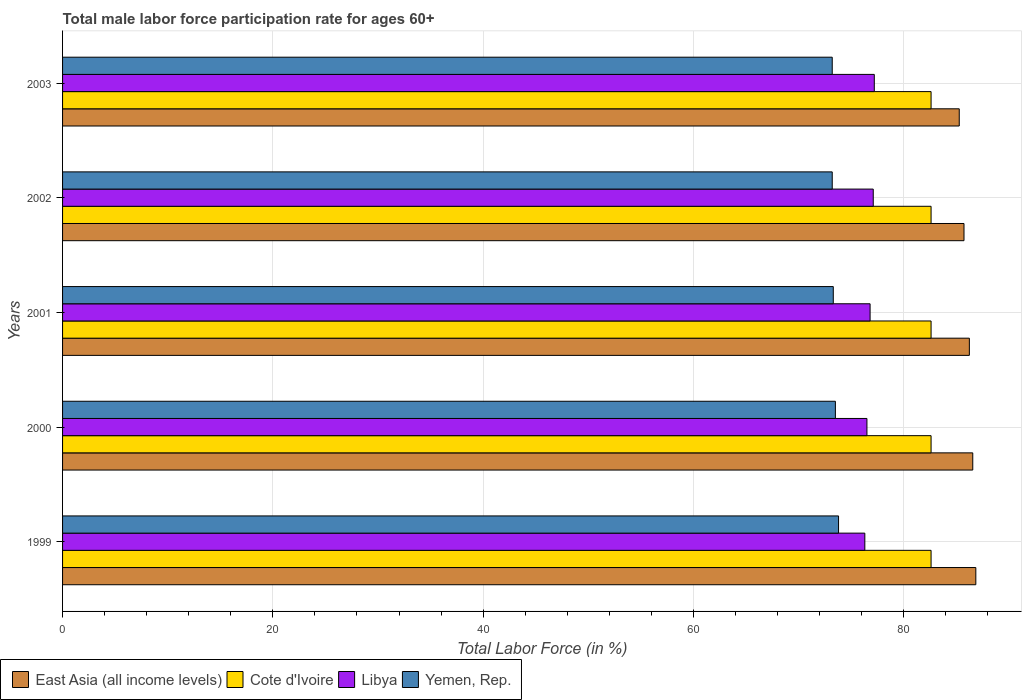How many different coloured bars are there?
Offer a very short reply. 4. How many groups of bars are there?
Provide a succinct answer. 5. Are the number of bars on each tick of the Y-axis equal?
Keep it short and to the point. Yes. What is the label of the 4th group of bars from the top?
Make the answer very short. 2000. In how many cases, is the number of bars for a given year not equal to the number of legend labels?
Your answer should be compact. 0. What is the male labor force participation rate in Cote d'Ivoire in 1999?
Keep it short and to the point. 82.6. Across all years, what is the maximum male labor force participation rate in Yemen, Rep.?
Offer a very short reply. 73.8. Across all years, what is the minimum male labor force participation rate in East Asia (all income levels)?
Keep it short and to the point. 85.28. What is the total male labor force participation rate in Yemen, Rep. in the graph?
Keep it short and to the point. 367. What is the difference between the male labor force participation rate in East Asia (all income levels) in 2002 and that in 2003?
Offer a very short reply. 0.45. What is the difference between the male labor force participation rate in Libya in 2000 and the male labor force participation rate in Cote d'Ivoire in 2002?
Offer a terse response. -6.1. What is the average male labor force participation rate in East Asia (all income levels) per year?
Your answer should be very brief. 86.13. In the year 2002, what is the difference between the male labor force participation rate in East Asia (all income levels) and male labor force participation rate in Libya?
Offer a very short reply. 8.63. Is the male labor force participation rate in East Asia (all income levels) in 1999 less than that in 2001?
Give a very brief answer. No. What is the difference between the highest and the second highest male labor force participation rate in Cote d'Ivoire?
Ensure brevity in your answer.  0. What is the difference between the highest and the lowest male labor force participation rate in Cote d'Ivoire?
Offer a terse response. 0. Is it the case that in every year, the sum of the male labor force participation rate in Cote d'Ivoire and male labor force participation rate in Yemen, Rep. is greater than the sum of male labor force participation rate in Libya and male labor force participation rate in East Asia (all income levels)?
Your answer should be very brief. Yes. What does the 2nd bar from the top in 2001 represents?
Offer a very short reply. Libya. What does the 2nd bar from the bottom in 2002 represents?
Provide a succinct answer. Cote d'Ivoire. How many bars are there?
Ensure brevity in your answer.  20. Are the values on the major ticks of X-axis written in scientific E-notation?
Your answer should be compact. No. Does the graph contain any zero values?
Your answer should be compact. No. How many legend labels are there?
Your answer should be very brief. 4. How are the legend labels stacked?
Offer a very short reply. Horizontal. What is the title of the graph?
Provide a succinct answer. Total male labor force participation rate for ages 60+. What is the label or title of the Y-axis?
Ensure brevity in your answer.  Years. What is the Total Labor Force (in %) of East Asia (all income levels) in 1999?
Provide a succinct answer. 86.86. What is the Total Labor Force (in %) of Cote d'Ivoire in 1999?
Your answer should be very brief. 82.6. What is the Total Labor Force (in %) in Libya in 1999?
Ensure brevity in your answer.  76.3. What is the Total Labor Force (in %) in Yemen, Rep. in 1999?
Keep it short and to the point. 73.8. What is the Total Labor Force (in %) of East Asia (all income levels) in 2000?
Provide a short and direct response. 86.56. What is the Total Labor Force (in %) in Cote d'Ivoire in 2000?
Keep it short and to the point. 82.6. What is the Total Labor Force (in %) in Libya in 2000?
Your answer should be very brief. 76.5. What is the Total Labor Force (in %) of Yemen, Rep. in 2000?
Keep it short and to the point. 73.5. What is the Total Labor Force (in %) of East Asia (all income levels) in 2001?
Give a very brief answer. 86.24. What is the Total Labor Force (in %) of Cote d'Ivoire in 2001?
Give a very brief answer. 82.6. What is the Total Labor Force (in %) in Libya in 2001?
Your answer should be very brief. 76.8. What is the Total Labor Force (in %) of Yemen, Rep. in 2001?
Your answer should be very brief. 73.3. What is the Total Labor Force (in %) in East Asia (all income levels) in 2002?
Your answer should be compact. 85.73. What is the Total Labor Force (in %) of Cote d'Ivoire in 2002?
Make the answer very short. 82.6. What is the Total Labor Force (in %) in Libya in 2002?
Provide a short and direct response. 77.1. What is the Total Labor Force (in %) of Yemen, Rep. in 2002?
Offer a very short reply. 73.2. What is the Total Labor Force (in %) of East Asia (all income levels) in 2003?
Your response must be concise. 85.28. What is the Total Labor Force (in %) in Cote d'Ivoire in 2003?
Offer a very short reply. 82.6. What is the Total Labor Force (in %) in Libya in 2003?
Give a very brief answer. 77.2. What is the Total Labor Force (in %) of Yemen, Rep. in 2003?
Give a very brief answer. 73.2. Across all years, what is the maximum Total Labor Force (in %) in East Asia (all income levels)?
Ensure brevity in your answer.  86.86. Across all years, what is the maximum Total Labor Force (in %) in Cote d'Ivoire?
Keep it short and to the point. 82.6. Across all years, what is the maximum Total Labor Force (in %) of Libya?
Offer a very short reply. 77.2. Across all years, what is the maximum Total Labor Force (in %) in Yemen, Rep.?
Provide a succinct answer. 73.8. Across all years, what is the minimum Total Labor Force (in %) in East Asia (all income levels)?
Your answer should be compact. 85.28. Across all years, what is the minimum Total Labor Force (in %) in Cote d'Ivoire?
Give a very brief answer. 82.6. Across all years, what is the minimum Total Labor Force (in %) in Libya?
Ensure brevity in your answer.  76.3. Across all years, what is the minimum Total Labor Force (in %) in Yemen, Rep.?
Offer a very short reply. 73.2. What is the total Total Labor Force (in %) in East Asia (all income levels) in the graph?
Offer a terse response. 430.67. What is the total Total Labor Force (in %) in Cote d'Ivoire in the graph?
Keep it short and to the point. 413. What is the total Total Labor Force (in %) in Libya in the graph?
Your answer should be very brief. 383.9. What is the total Total Labor Force (in %) of Yemen, Rep. in the graph?
Your response must be concise. 367. What is the difference between the Total Labor Force (in %) of East Asia (all income levels) in 1999 and that in 2000?
Provide a succinct answer. 0.29. What is the difference between the Total Labor Force (in %) in Libya in 1999 and that in 2000?
Provide a short and direct response. -0.2. What is the difference between the Total Labor Force (in %) of Yemen, Rep. in 1999 and that in 2000?
Give a very brief answer. 0.3. What is the difference between the Total Labor Force (in %) of East Asia (all income levels) in 1999 and that in 2001?
Provide a succinct answer. 0.62. What is the difference between the Total Labor Force (in %) of Cote d'Ivoire in 1999 and that in 2001?
Provide a short and direct response. 0. What is the difference between the Total Labor Force (in %) of Yemen, Rep. in 1999 and that in 2001?
Your answer should be compact. 0.5. What is the difference between the Total Labor Force (in %) of East Asia (all income levels) in 1999 and that in 2002?
Make the answer very short. 1.13. What is the difference between the Total Labor Force (in %) of Cote d'Ivoire in 1999 and that in 2002?
Keep it short and to the point. 0. What is the difference between the Total Labor Force (in %) in East Asia (all income levels) in 1999 and that in 2003?
Keep it short and to the point. 1.58. What is the difference between the Total Labor Force (in %) in Libya in 1999 and that in 2003?
Your response must be concise. -0.9. What is the difference between the Total Labor Force (in %) in East Asia (all income levels) in 2000 and that in 2001?
Provide a succinct answer. 0.32. What is the difference between the Total Labor Force (in %) of Cote d'Ivoire in 2000 and that in 2001?
Provide a succinct answer. 0. What is the difference between the Total Labor Force (in %) in Libya in 2000 and that in 2001?
Provide a short and direct response. -0.3. What is the difference between the Total Labor Force (in %) in East Asia (all income levels) in 2000 and that in 2002?
Provide a succinct answer. 0.83. What is the difference between the Total Labor Force (in %) in East Asia (all income levels) in 2000 and that in 2003?
Provide a succinct answer. 1.28. What is the difference between the Total Labor Force (in %) of Cote d'Ivoire in 2000 and that in 2003?
Give a very brief answer. 0. What is the difference between the Total Labor Force (in %) of Yemen, Rep. in 2000 and that in 2003?
Your response must be concise. 0.3. What is the difference between the Total Labor Force (in %) in East Asia (all income levels) in 2001 and that in 2002?
Offer a very short reply. 0.51. What is the difference between the Total Labor Force (in %) of Libya in 2001 and that in 2002?
Offer a terse response. -0.3. What is the difference between the Total Labor Force (in %) in Yemen, Rep. in 2001 and that in 2002?
Provide a short and direct response. 0.1. What is the difference between the Total Labor Force (in %) of East Asia (all income levels) in 2001 and that in 2003?
Your answer should be very brief. 0.96. What is the difference between the Total Labor Force (in %) of Cote d'Ivoire in 2001 and that in 2003?
Give a very brief answer. 0. What is the difference between the Total Labor Force (in %) of Libya in 2001 and that in 2003?
Your answer should be very brief. -0.4. What is the difference between the Total Labor Force (in %) of Yemen, Rep. in 2001 and that in 2003?
Provide a succinct answer. 0.1. What is the difference between the Total Labor Force (in %) of East Asia (all income levels) in 2002 and that in 2003?
Give a very brief answer. 0.45. What is the difference between the Total Labor Force (in %) in Libya in 2002 and that in 2003?
Offer a very short reply. -0.1. What is the difference between the Total Labor Force (in %) of East Asia (all income levels) in 1999 and the Total Labor Force (in %) of Cote d'Ivoire in 2000?
Keep it short and to the point. 4.26. What is the difference between the Total Labor Force (in %) of East Asia (all income levels) in 1999 and the Total Labor Force (in %) of Libya in 2000?
Make the answer very short. 10.36. What is the difference between the Total Labor Force (in %) in East Asia (all income levels) in 1999 and the Total Labor Force (in %) in Yemen, Rep. in 2000?
Ensure brevity in your answer.  13.36. What is the difference between the Total Labor Force (in %) of Cote d'Ivoire in 1999 and the Total Labor Force (in %) of Libya in 2000?
Offer a very short reply. 6.1. What is the difference between the Total Labor Force (in %) of East Asia (all income levels) in 1999 and the Total Labor Force (in %) of Cote d'Ivoire in 2001?
Your response must be concise. 4.26. What is the difference between the Total Labor Force (in %) of East Asia (all income levels) in 1999 and the Total Labor Force (in %) of Libya in 2001?
Ensure brevity in your answer.  10.06. What is the difference between the Total Labor Force (in %) of East Asia (all income levels) in 1999 and the Total Labor Force (in %) of Yemen, Rep. in 2001?
Your answer should be compact. 13.56. What is the difference between the Total Labor Force (in %) of Cote d'Ivoire in 1999 and the Total Labor Force (in %) of Libya in 2001?
Your response must be concise. 5.8. What is the difference between the Total Labor Force (in %) in Cote d'Ivoire in 1999 and the Total Labor Force (in %) in Yemen, Rep. in 2001?
Keep it short and to the point. 9.3. What is the difference between the Total Labor Force (in %) in Libya in 1999 and the Total Labor Force (in %) in Yemen, Rep. in 2001?
Keep it short and to the point. 3. What is the difference between the Total Labor Force (in %) of East Asia (all income levels) in 1999 and the Total Labor Force (in %) of Cote d'Ivoire in 2002?
Ensure brevity in your answer.  4.26. What is the difference between the Total Labor Force (in %) of East Asia (all income levels) in 1999 and the Total Labor Force (in %) of Libya in 2002?
Your answer should be compact. 9.76. What is the difference between the Total Labor Force (in %) in East Asia (all income levels) in 1999 and the Total Labor Force (in %) in Yemen, Rep. in 2002?
Keep it short and to the point. 13.66. What is the difference between the Total Labor Force (in %) of Cote d'Ivoire in 1999 and the Total Labor Force (in %) of Libya in 2002?
Give a very brief answer. 5.5. What is the difference between the Total Labor Force (in %) of East Asia (all income levels) in 1999 and the Total Labor Force (in %) of Cote d'Ivoire in 2003?
Your answer should be compact. 4.26. What is the difference between the Total Labor Force (in %) of East Asia (all income levels) in 1999 and the Total Labor Force (in %) of Libya in 2003?
Your answer should be compact. 9.66. What is the difference between the Total Labor Force (in %) in East Asia (all income levels) in 1999 and the Total Labor Force (in %) in Yemen, Rep. in 2003?
Your answer should be very brief. 13.66. What is the difference between the Total Labor Force (in %) in Cote d'Ivoire in 1999 and the Total Labor Force (in %) in Yemen, Rep. in 2003?
Offer a terse response. 9.4. What is the difference between the Total Labor Force (in %) in Libya in 1999 and the Total Labor Force (in %) in Yemen, Rep. in 2003?
Your response must be concise. 3.1. What is the difference between the Total Labor Force (in %) in East Asia (all income levels) in 2000 and the Total Labor Force (in %) in Cote d'Ivoire in 2001?
Give a very brief answer. 3.96. What is the difference between the Total Labor Force (in %) of East Asia (all income levels) in 2000 and the Total Labor Force (in %) of Libya in 2001?
Offer a very short reply. 9.76. What is the difference between the Total Labor Force (in %) in East Asia (all income levels) in 2000 and the Total Labor Force (in %) in Yemen, Rep. in 2001?
Offer a very short reply. 13.26. What is the difference between the Total Labor Force (in %) in East Asia (all income levels) in 2000 and the Total Labor Force (in %) in Cote d'Ivoire in 2002?
Your answer should be compact. 3.96. What is the difference between the Total Labor Force (in %) of East Asia (all income levels) in 2000 and the Total Labor Force (in %) of Libya in 2002?
Your answer should be compact. 9.46. What is the difference between the Total Labor Force (in %) in East Asia (all income levels) in 2000 and the Total Labor Force (in %) in Yemen, Rep. in 2002?
Your answer should be compact. 13.36. What is the difference between the Total Labor Force (in %) of Cote d'Ivoire in 2000 and the Total Labor Force (in %) of Libya in 2002?
Give a very brief answer. 5.5. What is the difference between the Total Labor Force (in %) of Libya in 2000 and the Total Labor Force (in %) of Yemen, Rep. in 2002?
Make the answer very short. 3.3. What is the difference between the Total Labor Force (in %) of East Asia (all income levels) in 2000 and the Total Labor Force (in %) of Cote d'Ivoire in 2003?
Keep it short and to the point. 3.96. What is the difference between the Total Labor Force (in %) of East Asia (all income levels) in 2000 and the Total Labor Force (in %) of Libya in 2003?
Offer a very short reply. 9.36. What is the difference between the Total Labor Force (in %) of East Asia (all income levels) in 2000 and the Total Labor Force (in %) of Yemen, Rep. in 2003?
Offer a terse response. 13.36. What is the difference between the Total Labor Force (in %) of Cote d'Ivoire in 2000 and the Total Labor Force (in %) of Yemen, Rep. in 2003?
Your answer should be very brief. 9.4. What is the difference between the Total Labor Force (in %) of Libya in 2000 and the Total Labor Force (in %) of Yemen, Rep. in 2003?
Offer a terse response. 3.3. What is the difference between the Total Labor Force (in %) of East Asia (all income levels) in 2001 and the Total Labor Force (in %) of Cote d'Ivoire in 2002?
Offer a terse response. 3.64. What is the difference between the Total Labor Force (in %) of East Asia (all income levels) in 2001 and the Total Labor Force (in %) of Libya in 2002?
Provide a succinct answer. 9.14. What is the difference between the Total Labor Force (in %) of East Asia (all income levels) in 2001 and the Total Labor Force (in %) of Yemen, Rep. in 2002?
Keep it short and to the point. 13.04. What is the difference between the Total Labor Force (in %) in Cote d'Ivoire in 2001 and the Total Labor Force (in %) in Libya in 2002?
Keep it short and to the point. 5.5. What is the difference between the Total Labor Force (in %) in Cote d'Ivoire in 2001 and the Total Labor Force (in %) in Yemen, Rep. in 2002?
Your response must be concise. 9.4. What is the difference between the Total Labor Force (in %) in East Asia (all income levels) in 2001 and the Total Labor Force (in %) in Cote d'Ivoire in 2003?
Keep it short and to the point. 3.64. What is the difference between the Total Labor Force (in %) in East Asia (all income levels) in 2001 and the Total Labor Force (in %) in Libya in 2003?
Your response must be concise. 9.04. What is the difference between the Total Labor Force (in %) of East Asia (all income levels) in 2001 and the Total Labor Force (in %) of Yemen, Rep. in 2003?
Offer a terse response. 13.04. What is the difference between the Total Labor Force (in %) of Libya in 2001 and the Total Labor Force (in %) of Yemen, Rep. in 2003?
Give a very brief answer. 3.6. What is the difference between the Total Labor Force (in %) of East Asia (all income levels) in 2002 and the Total Labor Force (in %) of Cote d'Ivoire in 2003?
Keep it short and to the point. 3.13. What is the difference between the Total Labor Force (in %) of East Asia (all income levels) in 2002 and the Total Labor Force (in %) of Libya in 2003?
Provide a short and direct response. 8.53. What is the difference between the Total Labor Force (in %) of East Asia (all income levels) in 2002 and the Total Labor Force (in %) of Yemen, Rep. in 2003?
Provide a succinct answer. 12.53. What is the difference between the Total Labor Force (in %) in Cote d'Ivoire in 2002 and the Total Labor Force (in %) in Yemen, Rep. in 2003?
Ensure brevity in your answer.  9.4. What is the average Total Labor Force (in %) of East Asia (all income levels) per year?
Offer a terse response. 86.13. What is the average Total Labor Force (in %) of Cote d'Ivoire per year?
Your answer should be compact. 82.6. What is the average Total Labor Force (in %) in Libya per year?
Provide a short and direct response. 76.78. What is the average Total Labor Force (in %) in Yemen, Rep. per year?
Ensure brevity in your answer.  73.4. In the year 1999, what is the difference between the Total Labor Force (in %) of East Asia (all income levels) and Total Labor Force (in %) of Cote d'Ivoire?
Give a very brief answer. 4.26. In the year 1999, what is the difference between the Total Labor Force (in %) of East Asia (all income levels) and Total Labor Force (in %) of Libya?
Give a very brief answer. 10.56. In the year 1999, what is the difference between the Total Labor Force (in %) in East Asia (all income levels) and Total Labor Force (in %) in Yemen, Rep.?
Your answer should be very brief. 13.06. In the year 1999, what is the difference between the Total Labor Force (in %) of Cote d'Ivoire and Total Labor Force (in %) of Yemen, Rep.?
Provide a succinct answer. 8.8. In the year 1999, what is the difference between the Total Labor Force (in %) of Libya and Total Labor Force (in %) of Yemen, Rep.?
Make the answer very short. 2.5. In the year 2000, what is the difference between the Total Labor Force (in %) of East Asia (all income levels) and Total Labor Force (in %) of Cote d'Ivoire?
Make the answer very short. 3.96. In the year 2000, what is the difference between the Total Labor Force (in %) in East Asia (all income levels) and Total Labor Force (in %) in Libya?
Make the answer very short. 10.06. In the year 2000, what is the difference between the Total Labor Force (in %) in East Asia (all income levels) and Total Labor Force (in %) in Yemen, Rep.?
Make the answer very short. 13.06. In the year 2000, what is the difference between the Total Labor Force (in %) in Cote d'Ivoire and Total Labor Force (in %) in Libya?
Offer a very short reply. 6.1. In the year 2000, what is the difference between the Total Labor Force (in %) in Cote d'Ivoire and Total Labor Force (in %) in Yemen, Rep.?
Keep it short and to the point. 9.1. In the year 2000, what is the difference between the Total Labor Force (in %) of Libya and Total Labor Force (in %) of Yemen, Rep.?
Keep it short and to the point. 3. In the year 2001, what is the difference between the Total Labor Force (in %) of East Asia (all income levels) and Total Labor Force (in %) of Cote d'Ivoire?
Give a very brief answer. 3.64. In the year 2001, what is the difference between the Total Labor Force (in %) of East Asia (all income levels) and Total Labor Force (in %) of Libya?
Your answer should be very brief. 9.44. In the year 2001, what is the difference between the Total Labor Force (in %) in East Asia (all income levels) and Total Labor Force (in %) in Yemen, Rep.?
Your answer should be compact. 12.94. In the year 2001, what is the difference between the Total Labor Force (in %) in Cote d'Ivoire and Total Labor Force (in %) in Yemen, Rep.?
Make the answer very short. 9.3. In the year 2001, what is the difference between the Total Labor Force (in %) in Libya and Total Labor Force (in %) in Yemen, Rep.?
Ensure brevity in your answer.  3.5. In the year 2002, what is the difference between the Total Labor Force (in %) of East Asia (all income levels) and Total Labor Force (in %) of Cote d'Ivoire?
Offer a very short reply. 3.13. In the year 2002, what is the difference between the Total Labor Force (in %) of East Asia (all income levels) and Total Labor Force (in %) of Libya?
Your response must be concise. 8.63. In the year 2002, what is the difference between the Total Labor Force (in %) in East Asia (all income levels) and Total Labor Force (in %) in Yemen, Rep.?
Offer a very short reply. 12.53. In the year 2002, what is the difference between the Total Labor Force (in %) in Cote d'Ivoire and Total Labor Force (in %) in Libya?
Offer a terse response. 5.5. In the year 2002, what is the difference between the Total Labor Force (in %) of Cote d'Ivoire and Total Labor Force (in %) of Yemen, Rep.?
Provide a short and direct response. 9.4. In the year 2002, what is the difference between the Total Labor Force (in %) of Libya and Total Labor Force (in %) of Yemen, Rep.?
Your response must be concise. 3.9. In the year 2003, what is the difference between the Total Labor Force (in %) in East Asia (all income levels) and Total Labor Force (in %) in Cote d'Ivoire?
Offer a very short reply. 2.68. In the year 2003, what is the difference between the Total Labor Force (in %) in East Asia (all income levels) and Total Labor Force (in %) in Libya?
Give a very brief answer. 8.08. In the year 2003, what is the difference between the Total Labor Force (in %) of East Asia (all income levels) and Total Labor Force (in %) of Yemen, Rep.?
Ensure brevity in your answer.  12.08. In the year 2003, what is the difference between the Total Labor Force (in %) in Cote d'Ivoire and Total Labor Force (in %) in Libya?
Provide a short and direct response. 5.4. What is the ratio of the Total Labor Force (in %) of Cote d'Ivoire in 1999 to that in 2000?
Ensure brevity in your answer.  1. What is the ratio of the Total Labor Force (in %) of Libya in 1999 to that in 2000?
Your answer should be compact. 1. What is the ratio of the Total Labor Force (in %) in East Asia (all income levels) in 1999 to that in 2001?
Your answer should be very brief. 1.01. What is the ratio of the Total Labor Force (in %) in Cote d'Ivoire in 1999 to that in 2001?
Provide a succinct answer. 1. What is the ratio of the Total Labor Force (in %) of Yemen, Rep. in 1999 to that in 2001?
Keep it short and to the point. 1.01. What is the ratio of the Total Labor Force (in %) of East Asia (all income levels) in 1999 to that in 2002?
Make the answer very short. 1.01. What is the ratio of the Total Labor Force (in %) in Cote d'Ivoire in 1999 to that in 2002?
Your answer should be compact. 1. What is the ratio of the Total Labor Force (in %) in Libya in 1999 to that in 2002?
Keep it short and to the point. 0.99. What is the ratio of the Total Labor Force (in %) in Yemen, Rep. in 1999 to that in 2002?
Offer a terse response. 1.01. What is the ratio of the Total Labor Force (in %) of East Asia (all income levels) in 1999 to that in 2003?
Your answer should be compact. 1.02. What is the ratio of the Total Labor Force (in %) in Libya in 1999 to that in 2003?
Make the answer very short. 0.99. What is the ratio of the Total Labor Force (in %) of Yemen, Rep. in 1999 to that in 2003?
Provide a succinct answer. 1.01. What is the ratio of the Total Labor Force (in %) of Cote d'Ivoire in 2000 to that in 2001?
Provide a succinct answer. 1. What is the ratio of the Total Labor Force (in %) in East Asia (all income levels) in 2000 to that in 2002?
Your answer should be very brief. 1.01. What is the ratio of the Total Labor Force (in %) in Cote d'Ivoire in 2000 to that in 2002?
Provide a succinct answer. 1. What is the ratio of the Total Labor Force (in %) of Libya in 2000 to that in 2002?
Ensure brevity in your answer.  0.99. What is the ratio of the Total Labor Force (in %) of East Asia (all income levels) in 2000 to that in 2003?
Make the answer very short. 1.02. What is the ratio of the Total Labor Force (in %) in Cote d'Ivoire in 2000 to that in 2003?
Your response must be concise. 1. What is the ratio of the Total Labor Force (in %) in Libya in 2000 to that in 2003?
Provide a short and direct response. 0.99. What is the ratio of the Total Labor Force (in %) in Yemen, Rep. in 2000 to that in 2003?
Ensure brevity in your answer.  1. What is the ratio of the Total Labor Force (in %) of Cote d'Ivoire in 2001 to that in 2002?
Your answer should be very brief. 1. What is the ratio of the Total Labor Force (in %) of Yemen, Rep. in 2001 to that in 2002?
Give a very brief answer. 1. What is the ratio of the Total Labor Force (in %) of East Asia (all income levels) in 2001 to that in 2003?
Offer a very short reply. 1.01. What is the ratio of the Total Labor Force (in %) in Cote d'Ivoire in 2001 to that in 2003?
Ensure brevity in your answer.  1. What is the ratio of the Total Labor Force (in %) in Yemen, Rep. in 2001 to that in 2003?
Offer a very short reply. 1. What is the ratio of the Total Labor Force (in %) of East Asia (all income levels) in 2002 to that in 2003?
Provide a short and direct response. 1.01. What is the ratio of the Total Labor Force (in %) of Cote d'Ivoire in 2002 to that in 2003?
Your response must be concise. 1. What is the ratio of the Total Labor Force (in %) in Yemen, Rep. in 2002 to that in 2003?
Your answer should be very brief. 1. What is the difference between the highest and the second highest Total Labor Force (in %) in East Asia (all income levels)?
Give a very brief answer. 0.29. What is the difference between the highest and the second highest Total Labor Force (in %) in Yemen, Rep.?
Keep it short and to the point. 0.3. What is the difference between the highest and the lowest Total Labor Force (in %) in East Asia (all income levels)?
Provide a short and direct response. 1.58. What is the difference between the highest and the lowest Total Labor Force (in %) in Cote d'Ivoire?
Your answer should be very brief. 0. What is the difference between the highest and the lowest Total Labor Force (in %) of Yemen, Rep.?
Make the answer very short. 0.6. 